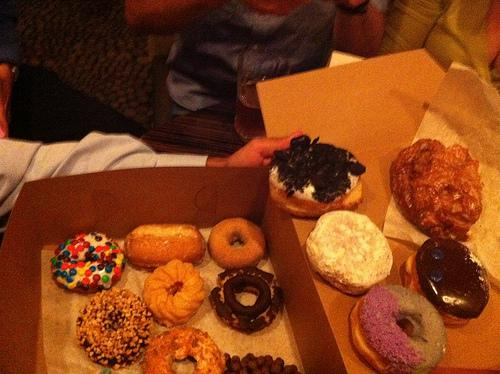Question: how many doughnuts are there?
Choices:
A. Thirteen.
B. Twelve.
C. Six.
D. One.
Answer with the letter. Answer: A Question: who made the doughnuts?
Choices:
A. A nice lady.
B. The neighbor boy.
C. A farmer.
D. The baker.
Answer with the letter. Answer: D 